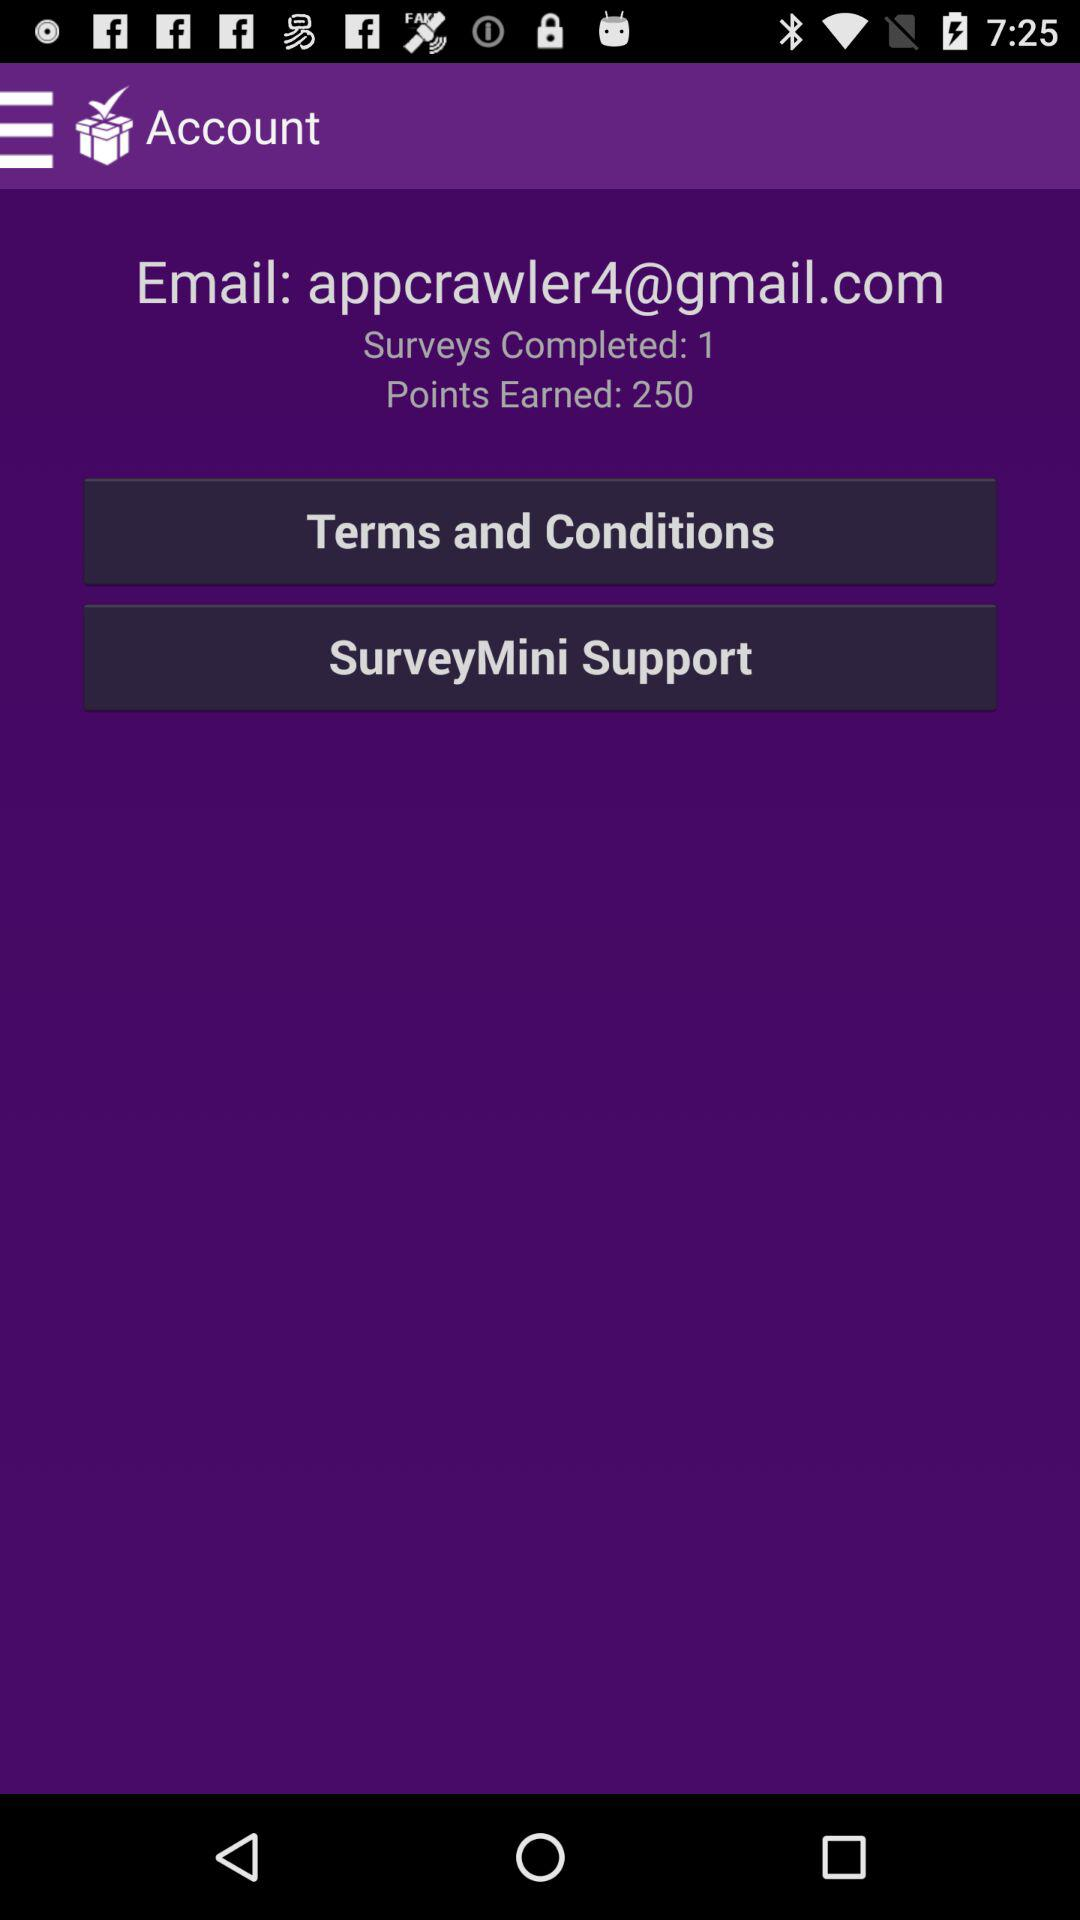How many more points have I earned than surveys I have completed?
Answer the question using a single word or phrase. 249 